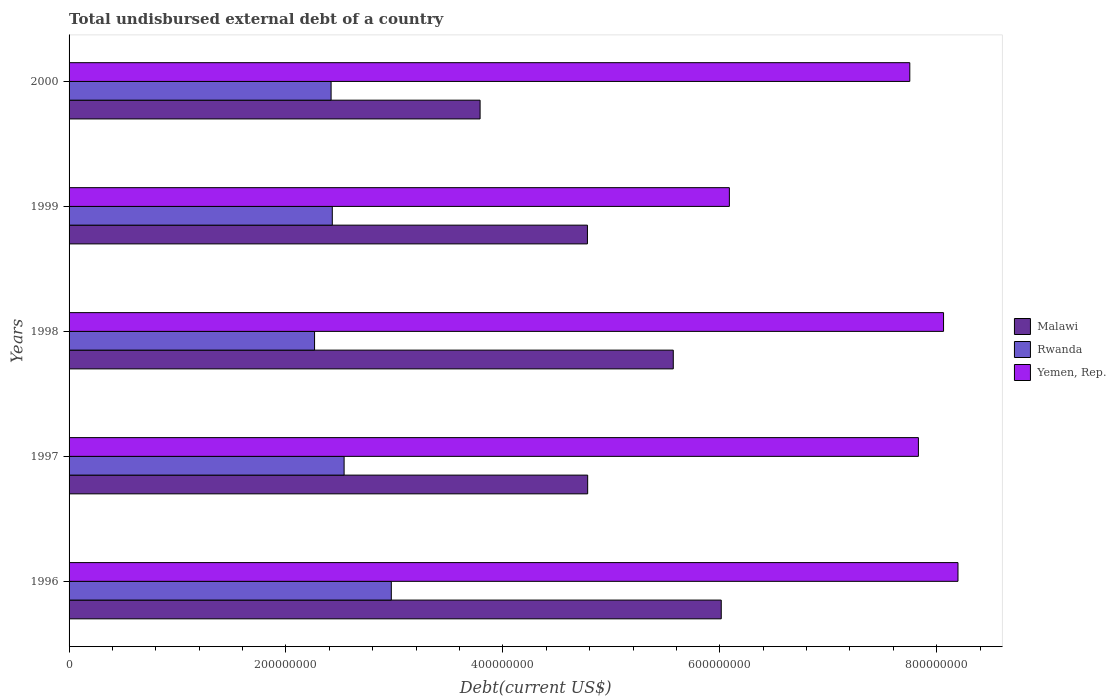How many different coloured bars are there?
Provide a succinct answer. 3. Are the number of bars per tick equal to the number of legend labels?
Your answer should be very brief. Yes. Are the number of bars on each tick of the Y-axis equal?
Offer a very short reply. Yes. How many bars are there on the 4th tick from the top?
Ensure brevity in your answer.  3. What is the label of the 5th group of bars from the top?
Keep it short and to the point. 1996. What is the total undisbursed external debt in Rwanda in 1996?
Offer a very short reply. 2.97e+08. Across all years, what is the maximum total undisbursed external debt in Malawi?
Offer a terse response. 6.01e+08. Across all years, what is the minimum total undisbursed external debt in Yemen, Rep.?
Offer a terse response. 6.09e+08. What is the total total undisbursed external debt in Malawi in the graph?
Give a very brief answer. 2.49e+09. What is the difference between the total undisbursed external debt in Malawi in 1998 and that in 2000?
Offer a very short reply. 1.78e+08. What is the difference between the total undisbursed external debt in Malawi in 1997 and the total undisbursed external debt in Yemen, Rep. in 1998?
Provide a short and direct response. -3.28e+08. What is the average total undisbursed external debt in Rwanda per year?
Provide a short and direct response. 2.52e+08. In the year 1996, what is the difference between the total undisbursed external debt in Rwanda and total undisbursed external debt in Malawi?
Ensure brevity in your answer.  -3.04e+08. What is the ratio of the total undisbursed external debt in Yemen, Rep. in 1999 to that in 2000?
Provide a succinct answer. 0.79. What is the difference between the highest and the second highest total undisbursed external debt in Yemen, Rep.?
Your response must be concise. 1.33e+07. What is the difference between the highest and the lowest total undisbursed external debt in Yemen, Rep.?
Ensure brevity in your answer.  2.11e+08. In how many years, is the total undisbursed external debt in Yemen, Rep. greater than the average total undisbursed external debt in Yemen, Rep. taken over all years?
Your answer should be very brief. 4. Is the sum of the total undisbursed external debt in Malawi in 1997 and 1999 greater than the maximum total undisbursed external debt in Yemen, Rep. across all years?
Your answer should be compact. Yes. What does the 3rd bar from the top in 1997 represents?
Offer a terse response. Malawi. What does the 3rd bar from the bottom in 1998 represents?
Your answer should be compact. Yemen, Rep. How many bars are there?
Provide a short and direct response. 15. What is the difference between two consecutive major ticks on the X-axis?
Your answer should be compact. 2.00e+08. How many legend labels are there?
Offer a terse response. 3. How are the legend labels stacked?
Your answer should be very brief. Vertical. What is the title of the graph?
Your response must be concise. Total undisbursed external debt of a country. What is the label or title of the X-axis?
Provide a short and direct response. Debt(current US$). What is the label or title of the Y-axis?
Your answer should be compact. Years. What is the Debt(current US$) in Malawi in 1996?
Provide a short and direct response. 6.01e+08. What is the Debt(current US$) of Rwanda in 1996?
Ensure brevity in your answer.  2.97e+08. What is the Debt(current US$) in Yemen, Rep. in 1996?
Provide a succinct answer. 8.20e+08. What is the Debt(current US$) of Malawi in 1997?
Your answer should be compact. 4.78e+08. What is the Debt(current US$) in Rwanda in 1997?
Ensure brevity in your answer.  2.54e+08. What is the Debt(current US$) of Yemen, Rep. in 1997?
Offer a terse response. 7.83e+08. What is the Debt(current US$) in Malawi in 1998?
Your answer should be very brief. 5.57e+08. What is the Debt(current US$) of Rwanda in 1998?
Keep it short and to the point. 2.26e+08. What is the Debt(current US$) in Yemen, Rep. in 1998?
Offer a very short reply. 8.06e+08. What is the Debt(current US$) in Malawi in 1999?
Ensure brevity in your answer.  4.78e+08. What is the Debt(current US$) of Rwanda in 1999?
Keep it short and to the point. 2.43e+08. What is the Debt(current US$) of Yemen, Rep. in 1999?
Offer a very short reply. 6.09e+08. What is the Debt(current US$) of Malawi in 2000?
Your answer should be compact. 3.79e+08. What is the Debt(current US$) of Rwanda in 2000?
Give a very brief answer. 2.42e+08. What is the Debt(current US$) of Yemen, Rep. in 2000?
Your answer should be very brief. 7.75e+08. Across all years, what is the maximum Debt(current US$) of Malawi?
Provide a short and direct response. 6.01e+08. Across all years, what is the maximum Debt(current US$) in Rwanda?
Provide a succinct answer. 2.97e+08. Across all years, what is the maximum Debt(current US$) in Yemen, Rep.?
Your answer should be very brief. 8.20e+08. Across all years, what is the minimum Debt(current US$) of Malawi?
Keep it short and to the point. 3.79e+08. Across all years, what is the minimum Debt(current US$) in Rwanda?
Ensure brevity in your answer.  2.26e+08. Across all years, what is the minimum Debt(current US$) of Yemen, Rep.?
Provide a succinct answer. 6.09e+08. What is the total Debt(current US$) of Malawi in the graph?
Provide a succinct answer. 2.49e+09. What is the total Debt(current US$) of Rwanda in the graph?
Ensure brevity in your answer.  1.26e+09. What is the total Debt(current US$) of Yemen, Rep. in the graph?
Offer a terse response. 3.79e+09. What is the difference between the Debt(current US$) of Malawi in 1996 and that in 1997?
Make the answer very short. 1.23e+08. What is the difference between the Debt(current US$) in Rwanda in 1996 and that in 1997?
Your response must be concise. 4.35e+07. What is the difference between the Debt(current US$) of Yemen, Rep. in 1996 and that in 1997?
Your answer should be very brief. 3.65e+07. What is the difference between the Debt(current US$) in Malawi in 1996 and that in 1998?
Your answer should be compact. 4.42e+07. What is the difference between the Debt(current US$) in Rwanda in 1996 and that in 1998?
Your answer should be compact. 7.08e+07. What is the difference between the Debt(current US$) in Yemen, Rep. in 1996 and that in 1998?
Your response must be concise. 1.33e+07. What is the difference between the Debt(current US$) of Malawi in 1996 and that in 1999?
Make the answer very short. 1.23e+08. What is the difference between the Debt(current US$) in Rwanda in 1996 and that in 1999?
Your answer should be very brief. 5.44e+07. What is the difference between the Debt(current US$) of Yemen, Rep. in 1996 and that in 1999?
Give a very brief answer. 2.11e+08. What is the difference between the Debt(current US$) in Malawi in 1996 and that in 2000?
Give a very brief answer. 2.22e+08. What is the difference between the Debt(current US$) of Rwanda in 1996 and that in 2000?
Give a very brief answer. 5.55e+07. What is the difference between the Debt(current US$) in Yemen, Rep. in 1996 and that in 2000?
Offer a terse response. 4.44e+07. What is the difference between the Debt(current US$) in Malawi in 1997 and that in 1998?
Give a very brief answer. -7.89e+07. What is the difference between the Debt(current US$) of Rwanda in 1997 and that in 1998?
Keep it short and to the point. 2.73e+07. What is the difference between the Debt(current US$) in Yemen, Rep. in 1997 and that in 1998?
Your answer should be compact. -2.32e+07. What is the difference between the Debt(current US$) of Malawi in 1997 and that in 1999?
Your answer should be very brief. 2.07e+05. What is the difference between the Debt(current US$) of Rwanda in 1997 and that in 1999?
Keep it short and to the point. 1.09e+07. What is the difference between the Debt(current US$) in Yemen, Rep. in 1997 and that in 1999?
Give a very brief answer. 1.74e+08. What is the difference between the Debt(current US$) in Malawi in 1997 and that in 2000?
Your answer should be compact. 9.92e+07. What is the difference between the Debt(current US$) in Rwanda in 1997 and that in 2000?
Offer a very short reply. 1.20e+07. What is the difference between the Debt(current US$) of Yemen, Rep. in 1997 and that in 2000?
Give a very brief answer. 7.94e+06. What is the difference between the Debt(current US$) of Malawi in 1998 and that in 1999?
Give a very brief answer. 7.92e+07. What is the difference between the Debt(current US$) of Rwanda in 1998 and that in 1999?
Ensure brevity in your answer.  -1.64e+07. What is the difference between the Debt(current US$) of Yemen, Rep. in 1998 and that in 1999?
Make the answer very short. 1.97e+08. What is the difference between the Debt(current US$) of Malawi in 1998 and that in 2000?
Provide a succinct answer. 1.78e+08. What is the difference between the Debt(current US$) of Rwanda in 1998 and that in 2000?
Give a very brief answer. -1.52e+07. What is the difference between the Debt(current US$) of Yemen, Rep. in 1998 and that in 2000?
Your answer should be compact. 3.11e+07. What is the difference between the Debt(current US$) in Malawi in 1999 and that in 2000?
Offer a terse response. 9.90e+07. What is the difference between the Debt(current US$) of Rwanda in 1999 and that in 2000?
Make the answer very short. 1.11e+06. What is the difference between the Debt(current US$) in Yemen, Rep. in 1999 and that in 2000?
Give a very brief answer. -1.66e+08. What is the difference between the Debt(current US$) in Malawi in 1996 and the Debt(current US$) in Rwanda in 1997?
Provide a short and direct response. 3.48e+08. What is the difference between the Debt(current US$) in Malawi in 1996 and the Debt(current US$) in Yemen, Rep. in 1997?
Your answer should be very brief. -1.82e+08. What is the difference between the Debt(current US$) of Rwanda in 1996 and the Debt(current US$) of Yemen, Rep. in 1997?
Make the answer very short. -4.86e+08. What is the difference between the Debt(current US$) in Malawi in 1996 and the Debt(current US$) in Rwanda in 1998?
Your answer should be compact. 3.75e+08. What is the difference between the Debt(current US$) in Malawi in 1996 and the Debt(current US$) in Yemen, Rep. in 1998?
Ensure brevity in your answer.  -2.05e+08. What is the difference between the Debt(current US$) of Rwanda in 1996 and the Debt(current US$) of Yemen, Rep. in 1998?
Keep it short and to the point. -5.09e+08. What is the difference between the Debt(current US$) of Malawi in 1996 and the Debt(current US$) of Rwanda in 1999?
Provide a short and direct response. 3.59e+08. What is the difference between the Debt(current US$) in Malawi in 1996 and the Debt(current US$) in Yemen, Rep. in 1999?
Make the answer very short. -7.49e+06. What is the difference between the Debt(current US$) in Rwanda in 1996 and the Debt(current US$) in Yemen, Rep. in 1999?
Your answer should be very brief. -3.12e+08. What is the difference between the Debt(current US$) of Malawi in 1996 and the Debt(current US$) of Rwanda in 2000?
Provide a succinct answer. 3.60e+08. What is the difference between the Debt(current US$) of Malawi in 1996 and the Debt(current US$) of Yemen, Rep. in 2000?
Give a very brief answer. -1.74e+08. What is the difference between the Debt(current US$) in Rwanda in 1996 and the Debt(current US$) in Yemen, Rep. in 2000?
Offer a very short reply. -4.78e+08. What is the difference between the Debt(current US$) in Malawi in 1997 and the Debt(current US$) in Rwanda in 1998?
Offer a terse response. 2.52e+08. What is the difference between the Debt(current US$) in Malawi in 1997 and the Debt(current US$) in Yemen, Rep. in 1998?
Offer a terse response. -3.28e+08. What is the difference between the Debt(current US$) in Rwanda in 1997 and the Debt(current US$) in Yemen, Rep. in 1998?
Your answer should be very brief. -5.53e+08. What is the difference between the Debt(current US$) in Malawi in 1997 and the Debt(current US$) in Rwanda in 1999?
Provide a succinct answer. 2.35e+08. What is the difference between the Debt(current US$) in Malawi in 1997 and the Debt(current US$) in Yemen, Rep. in 1999?
Ensure brevity in your answer.  -1.31e+08. What is the difference between the Debt(current US$) in Rwanda in 1997 and the Debt(current US$) in Yemen, Rep. in 1999?
Your answer should be compact. -3.55e+08. What is the difference between the Debt(current US$) of Malawi in 1997 and the Debt(current US$) of Rwanda in 2000?
Your answer should be very brief. 2.37e+08. What is the difference between the Debt(current US$) in Malawi in 1997 and the Debt(current US$) in Yemen, Rep. in 2000?
Provide a short and direct response. -2.97e+08. What is the difference between the Debt(current US$) in Rwanda in 1997 and the Debt(current US$) in Yemen, Rep. in 2000?
Offer a terse response. -5.22e+08. What is the difference between the Debt(current US$) of Malawi in 1998 and the Debt(current US$) of Rwanda in 1999?
Your response must be concise. 3.14e+08. What is the difference between the Debt(current US$) in Malawi in 1998 and the Debt(current US$) in Yemen, Rep. in 1999?
Offer a terse response. -5.17e+07. What is the difference between the Debt(current US$) of Rwanda in 1998 and the Debt(current US$) of Yemen, Rep. in 1999?
Offer a terse response. -3.82e+08. What is the difference between the Debt(current US$) in Malawi in 1998 and the Debt(current US$) in Rwanda in 2000?
Give a very brief answer. 3.16e+08. What is the difference between the Debt(current US$) of Malawi in 1998 and the Debt(current US$) of Yemen, Rep. in 2000?
Provide a short and direct response. -2.18e+08. What is the difference between the Debt(current US$) of Rwanda in 1998 and the Debt(current US$) of Yemen, Rep. in 2000?
Your response must be concise. -5.49e+08. What is the difference between the Debt(current US$) of Malawi in 1999 and the Debt(current US$) of Rwanda in 2000?
Your answer should be very brief. 2.36e+08. What is the difference between the Debt(current US$) in Malawi in 1999 and the Debt(current US$) in Yemen, Rep. in 2000?
Make the answer very short. -2.97e+08. What is the difference between the Debt(current US$) of Rwanda in 1999 and the Debt(current US$) of Yemen, Rep. in 2000?
Make the answer very short. -5.33e+08. What is the average Debt(current US$) in Malawi per year?
Offer a terse response. 4.99e+08. What is the average Debt(current US$) in Rwanda per year?
Make the answer very short. 2.52e+08. What is the average Debt(current US$) of Yemen, Rep. per year?
Provide a short and direct response. 7.59e+08. In the year 1996, what is the difference between the Debt(current US$) in Malawi and Debt(current US$) in Rwanda?
Ensure brevity in your answer.  3.04e+08. In the year 1996, what is the difference between the Debt(current US$) in Malawi and Debt(current US$) in Yemen, Rep.?
Ensure brevity in your answer.  -2.18e+08. In the year 1996, what is the difference between the Debt(current US$) of Rwanda and Debt(current US$) of Yemen, Rep.?
Your response must be concise. -5.23e+08. In the year 1997, what is the difference between the Debt(current US$) in Malawi and Debt(current US$) in Rwanda?
Your answer should be compact. 2.25e+08. In the year 1997, what is the difference between the Debt(current US$) of Malawi and Debt(current US$) of Yemen, Rep.?
Keep it short and to the point. -3.05e+08. In the year 1997, what is the difference between the Debt(current US$) in Rwanda and Debt(current US$) in Yemen, Rep.?
Offer a terse response. -5.30e+08. In the year 1998, what is the difference between the Debt(current US$) in Malawi and Debt(current US$) in Rwanda?
Your answer should be very brief. 3.31e+08. In the year 1998, what is the difference between the Debt(current US$) of Malawi and Debt(current US$) of Yemen, Rep.?
Your answer should be very brief. -2.49e+08. In the year 1998, what is the difference between the Debt(current US$) in Rwanda and Debt(current US$) in Yemen, Rep.?
Ensure brevity in your answer.  -5.80e+08. In the year 1999, what is the difference between the Debt(current US$) of Malawi and Debt(current US$) of Rwanda?
Make the answer very short. 2.35e+08. In the year 1999, what is the difference between the Debt(current US$) in Malawi and Debt(current US$) in Yemen, Rep.?
Provide a succinct answer. -1.31e+08. In the year 1999, what is the difference between the Debt(current US$) of Rwanda and Debt(current US$) of Yemen, Rep.?
Offer a very short reply. -3.66e+08. In the year 2000, what is the difference between the Debt(current US$) in Malawi and Debt(current US$) in Rwanda?
Ensure brevity in your answer.  1.37e+08. In the year 2000, what is the difference between the Debt(current US$) of Malawi and Debt(current US$) of Yemen, Rep.?
Offer a very short reply. -3.96e+08. In the year 2000, what is the difference between the Debt(current US$) of Rwanda and Debt(current US$) of Yemen, Rep.?
Your response must be concise. -5.34e+08. What is the ratio of the Debt(current US$) in Malawi in 1996 to that in 1997?
Provide a succinct answer. 1.26. What is the ratio of the Debt(current US$) in Rwanda in 1996 to that in 1997?
Provide a succinct answer. 1.17. What is the ratio of the Debt(current US$) in Yemen, Rep. in 1996 to that in 1997?
Ensure brevity in your answer.  1.05. What is the ratio of the Debt(current US$) of Malawi in 1996 to that in 1998?
Offer a very short reply. 1.08. What is the ratio of the Debt(current US$) in Rwanda in 1996 to that in 1998?
Provide a short and direct response. 1.31. What is the ratio of the Debt(current US$) in Yemen, Rep. in 1996 to that in 1998?
Give a very brief answer. 1.02. What is the ratio of the Debt(current US$) of Malawi in 1996 to that in 1999?
Offer a terse response. 1.26. What is the ratio of the Debt(current US$) of Rwanda in 1996 to that in 1999?
Provide a short and direct response. 1.22. What is the ratio of the Debt(current US$) in Yemen, Rep. in 1996 to that in 1999?
Offer a very short reply. 1.35. What is the ratio of the Debt(current US$) in Malawi in 1996 to that in 2000?
Offer a very short reply. 1.59. What is the ratio of the Debt(current US$) in Rwanda in 1996 to that in 2000?
Ensure brevity in your answer.  1.23. What is the ratio of the Debt(current US$) in Yemen, Rep. in 1996 to that in 2000?
Offer a terse response. 1.06. What is the ratio of the Debt(current US$) of Malawi in 1997 to that in 1998?
Your answer should be very brief. 0.86. What is the ratio of the Debt(current US$) of Rwanda in 1997 to that in 1998?
Ensure brevity in your answer.  1.12. What is the ratio of the Debt(current US$) in Yemen, Rep. in 1997 to that in 1998?
Your answer should be very brief. 0.97. What is the ratio of the Debt(current US$) in Rwanda in 1997 to that in 1999?
Provide a succinct answer. 1.04. What is the ratio of the Debt(current US$) in Yemen, Rep. in 1997 to that in 1999?
Your answer should be very brief. 1.29. What is the ratio of the Debt(current US$) of Malawi in 1997 to that in 2000?
Your response must be concise. 1.26. What is the ratio of the Debt(current US$) of Rwanda in 1997 to that in 2000?
Make the answer very short. 1.05. What is the ratio of the Debt(current US$) of Yemen, Rep. in 1997 to that in 2000?
Offer a very short reply. 1.01. What is the ratio of the Debt(current US$) in Malawi in 1998 to that in 1999?
Make the answer very short. 1.17. What is the ratio of the Debt(current US$) of Rwanda in 1998 to that in 1999?
Provide a short and direct response. 0.93. What is the ratio of the Debt(current US$) in Yemen, Rep. in 1998 to that in 1999?
Keep it short and to the point. 1.32. What is the ratio of the Debt(current US$) in Malawi in 1998 to that in 2000?
Your answer should be compact. 1.47. What is the ratio of the Debt(current US$) of Rwanda in 1998 to that in 2000?
Provide a short and direct response. 0.94. What is the ratio of the Debt(current US$) in Yemen, Rep. in 1998 to that in 2000?
Offer a terse response. 1.04. What is the ratio of the Debt(current US$) in Malawi in 1999 to that in 2000?
Give a very brief answer. 1.26. What is the ratio of the Debt(current US$) of Rwanda in 1999 to that in 2000?
Your answer should be very brief. 1. What is the ratio of the Debt(current US$) of Yemen, Rep. in 1999 to that in 2000?
Your answer should be compact. 0.79. What is the difference between the highest and the second highest Debt(current US$) in Malawi?
Your answer should be very brief. 4.42e+07. What is the difference between the highest and the second highest Debt(current US$) in Rwanda?
Keep it short and to the point. 4.35e+07. What is the difference between the highest and the second highest Debt(current US$) of Yemen, Rep.?
Provide a succinct answer. 1.33e+07. What is the difference between the highest and the lowest Debt(current US$) of Malawi?
Your answer should be very brief. 2.22e+08. What is the difference between the highest and the lowest Debt(current US$) in Rwanda?
Make the answer very short. 7.08e+07. What is the difference between the highest and the lowest Debt(current US$) in Yemen, Rep.?
Keep it short and to the point. 2.11e+08. 